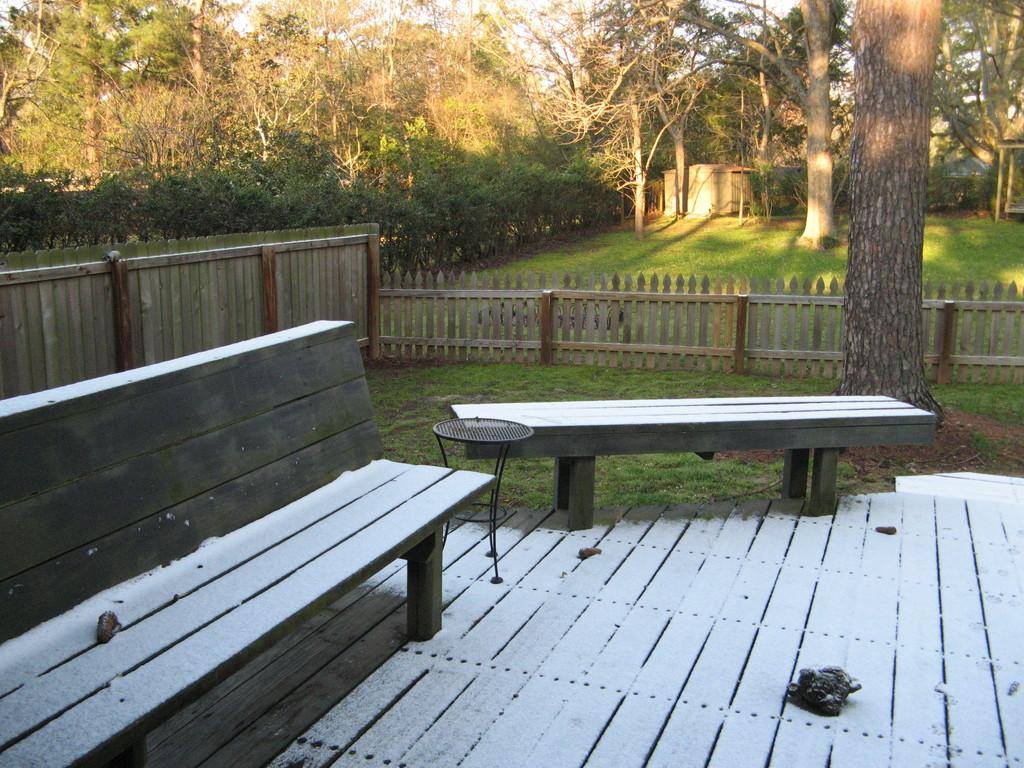How many benches are present in the image? There are two benches in the image. What can be seen in the background of the image? There are trees in the background of the image. What is the color of the trees? The trees are green in color. What is visible above the trees in the image? The sky is visible in the image. What is the color of the sky? The sky is white in color. What hobbies do the trees enjoy in the image? Trees do not have hobbies, as they are inanimate objects. 